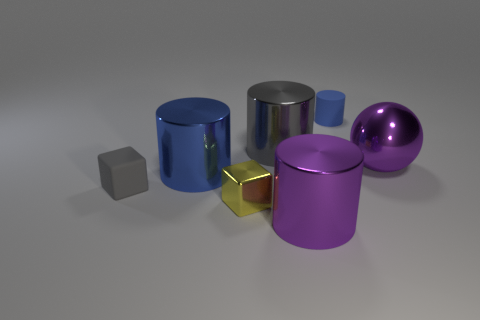The small thing that is both in front of the large blue metallic object and right of the tiny matte block has what shape?
Make the answer very short. Cube. There is a tiny matte thing right of the gray rubber block; is there a cylinder on the right side of it?
Keep it short and to the point. No. How many other objects are the same material as the small blue cylinder?
Offer a very short reply. 1. Does the big object in front of the large blue thing have the same shape as the gray thing behind the gray matte cube?
Provide a short and direct response. Yes. Is the material of the tiny cylinder the same as the big purple ball?
Keep it short and to the point. No. There is a gray object behind the gray object that is in front of the purple thing right of the tiny blue object; how big is it?
Your answer should be very brief. Large. What number of other objects are there of the same color as the sphere?
Make the answer very short. 1. What shape is the gray rubber object that is the same size as the yellow metal thing?
Provide a short and direct response. Cube. How many tiny objects are gray cubes or yellow blocks?
Offer a terse response. 2. Is there a yellow cube to the right of the purple metal object on the left side of the matte thing that is behind the tiny gray rubber thing?
Provide a succinct answer. No. 